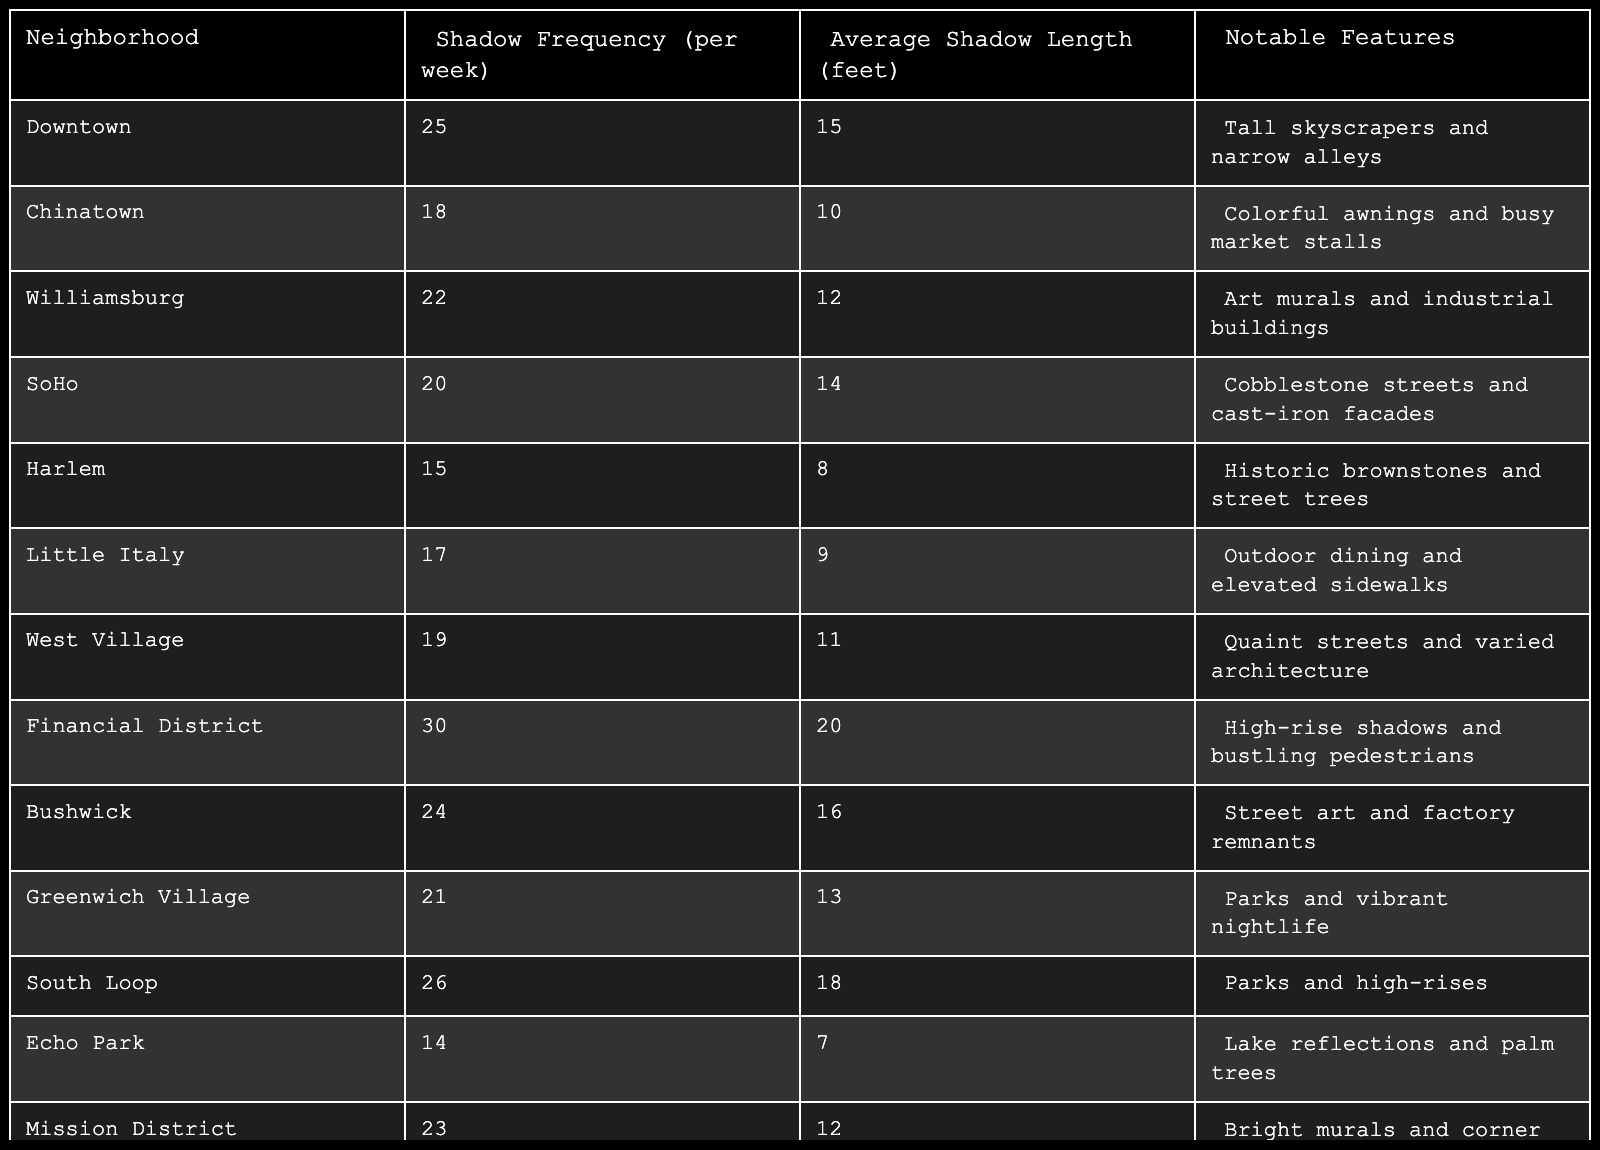What is the neighborhood with the highest shadow frequency? By reviewing the table, I can see that the Financial District has the highest shadow frequency at 30 occurrences per week.
Answer: Financial District How many neighborhoods have a shadow frequency of 20 or more? The neighborhoods with a shadow frequency of 20 or more are Downtown, Williamsburg, SoHo, Financial District, Bushwick, Greenwich Village, South Loop, and Mission District. That makes a total of 8 neighborhoods.
Answer: 8 What is the average shadow length across all neighborhoods? To find the average shadow length, I sum all the shadow lengths (15+10+12+14+8+9+11+20+16+13+18+7+12+10+11) which equals  195. Dividing by the number of neighborhoods (15), the average shadow length is 195/15 = 13 feet.
Answer: 13 feet Is there a neighborhood with a shadow frequency less than 15? Yes, the table shows that Echo Park has a shadow frequency of 14, which is less than 15.
Answer: Yes Which neighborhood has the longest average shadow length? According to the table, the Financial District has the longest average shadow length at 20 feet, which is greater than all other neighborhoods.
Answer: Financial District What is the difference between the highest and lowest shadow frequency? The highest shadow frequency is 30 (Financial District) and the lowest is 14 (Echo Park). Therefore, the difference is 30 - 14 = 16 occurrences.
Answer: 16 How many neighborhoods have notable features involving outdoor elements? The neighborhoods with notable outdoor features are Harlem (historic brownstones and street trees), Little Italy (outdoor dining), Pioneer Square (outdoor art), and South Loop (parks). This gives a total of 4 neighborhoods.
Answer: 4 What is the total shadow frequency for all neighborhoods combined? The total shadow frequency is the sum of all frequencies: 25 + 18 + 22 + 20 + 15 + 17 + 19 + 30 + 24 + 21 + 26 + 14 + 23 + 16 + 20 =  400 occurrences per week.
Answer: 400 Which neighborhood has a shadow length of 7 feet? The table shows that Echo Park has an average shadow length of 7 feet, which is the only neighborhood with this length.
Answer: Echo Park What is the average shadow frequency for neighborhoods with notable features including outdoor dining? The neighborhoods that have outdoor dining features are Little Italy and South Loop, with frequencies of 17 and 26, respectively. The average frequency is (17 + 26)/2 = 21.5 occurrences.
Answer: 21.5 occurrences 